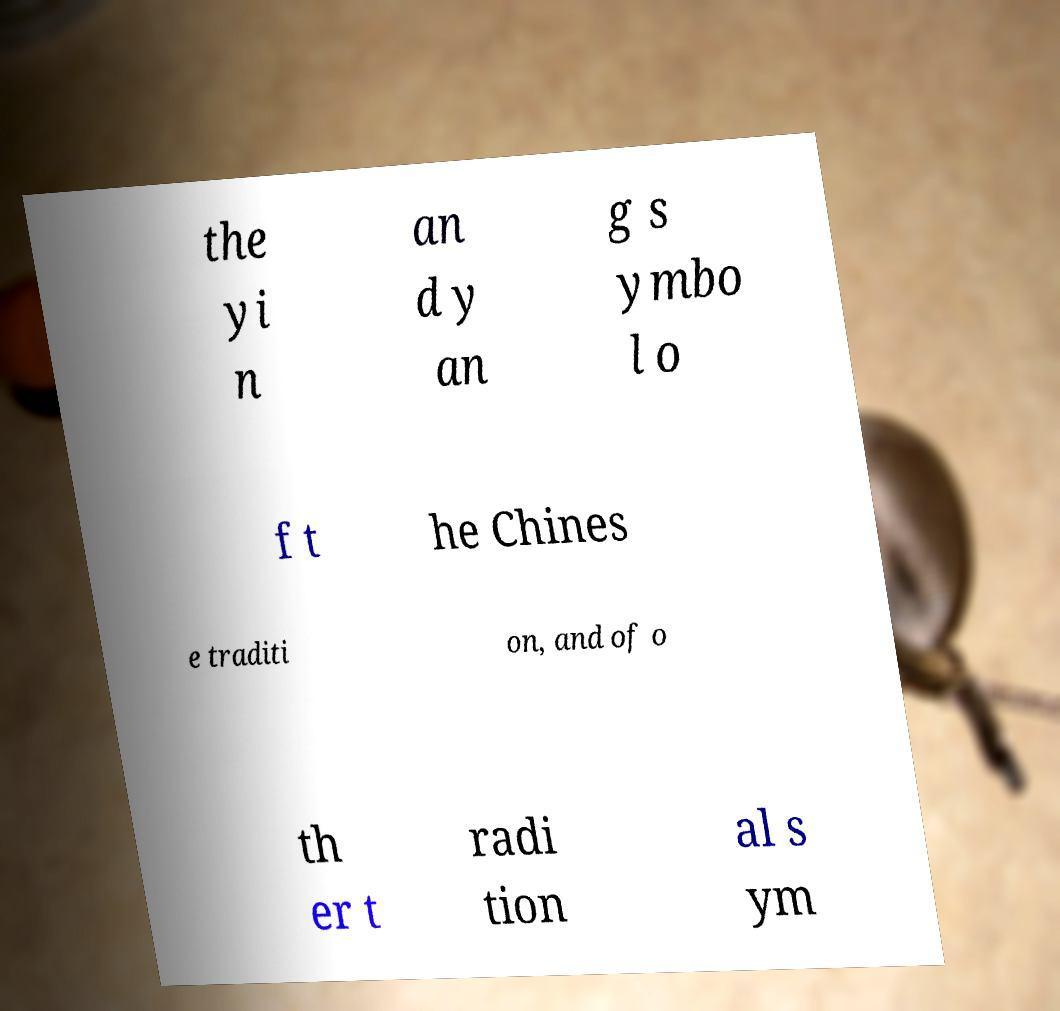What messages or text are displayed in this image? I need them in a readable, typed format. the yi n an d y an g s ymbo l o f t he Chines e traditi on, and of o th er t radi tion al s ym 